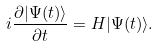<formula> <loc_0><loc_0><loc_500><loc_500>i \frac { \partial | \Psi ( t ) \rangle } { \partial t } = H | \Psi ( t ) \rangle .</formula> 